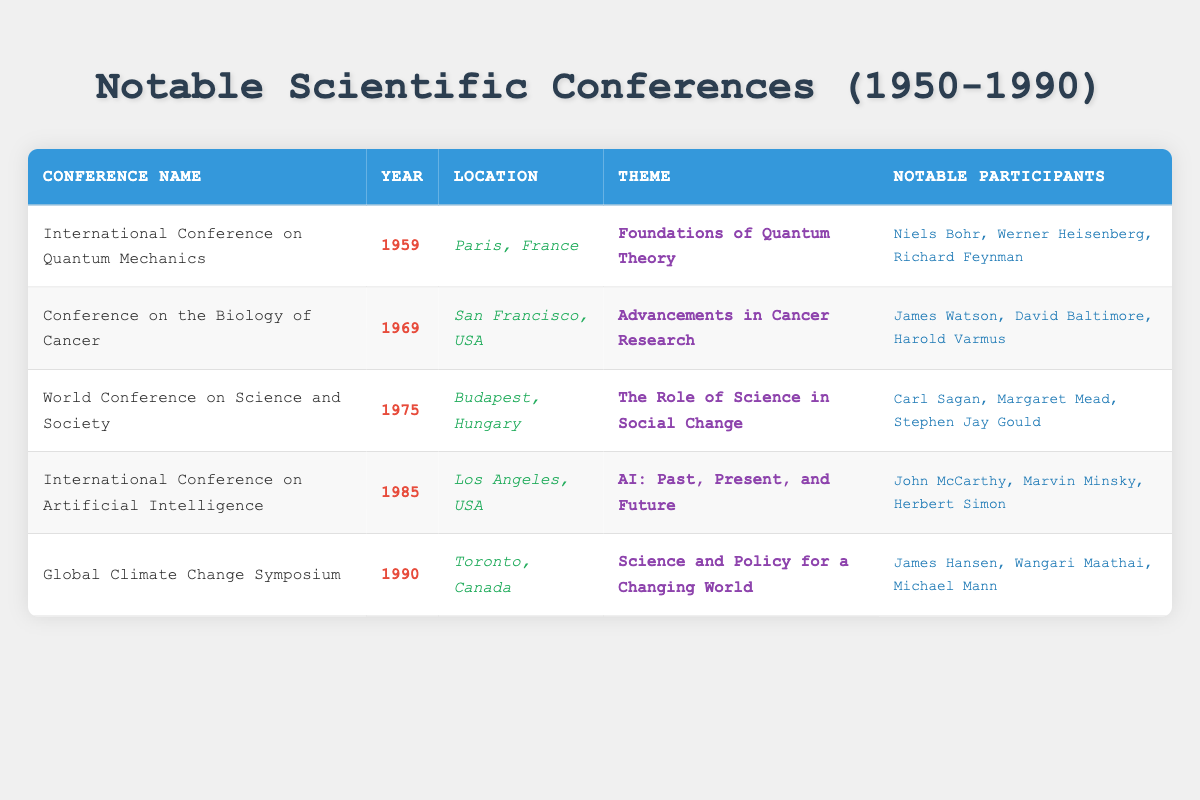What year was the International Conference on Quantum Mechanics held? The table shows that the International Conference on Quantum Mechanics is listed under the "Conference Name" column with the corresponding "Year" column reading 1959.
Answer: 1959 Which notable participant attended the Conference on the Biology of Cancer? Looking at the row for the Conference on the Biology of Cancer, the "Notable Participants" column lists James Watson, David Baltimore, and Harold Varmus.
Answer: James Watson True or False: The Global Climate Change Symposium took place in the USA. The location for the Global Climate Change Symposium in the table is Toronto, Canada, thus it was not held in the USA.
Answer: False How many notable conferences took place in the 1970s? By checking the years in the table, there is one conference held in the 1970s, which is the World Conference on Science and Society (1975).
Answer: 1 Which conference theme focused on social issues? The table points to the World Conference on Science and Society with the theme "The Role of Science in Social Change" as the one that addresses social issues.
Answer: The Role of Science in Social Change List the locations of all conferences that occurred before 1980. The table shows the following conferences before 1980: International Conference on Quantum Mechanics in Paris, France; Conference on the Biology of Cancer in San Francisco, USA; and World Conference on Science and Society in Budapest, Hungary.
Answer: Paris, France; San Francisco, USA; Budapest, Hungary What was the average year of the conferences listed in the table? To find the average, add the years (1959 + 1969 + 1975 + 1985 + 1990 = 9979) and divide by the number of conferences (5). Thus, 9979/5 = 1995.8, rounded to the nearest whole year gives approximately 1996.
Answer: 1996 How many of the notable participants in the 1985 conference are also widely recognized in the field of computer science? The notable participants of the 1985 conference include John McCarthy and Marvin Minsky, both of whom are well-known figures in computer science, making a total of two.
Answer: 2 Which conference in 1969 featured advancements in cancer research? It is indicated in the table that the conference held in 1969 was the Conference on the Biology of Cancer, with the specific theme being "Advancements in Cancer Research."
Answer: Conference on the Biology of Cancer 